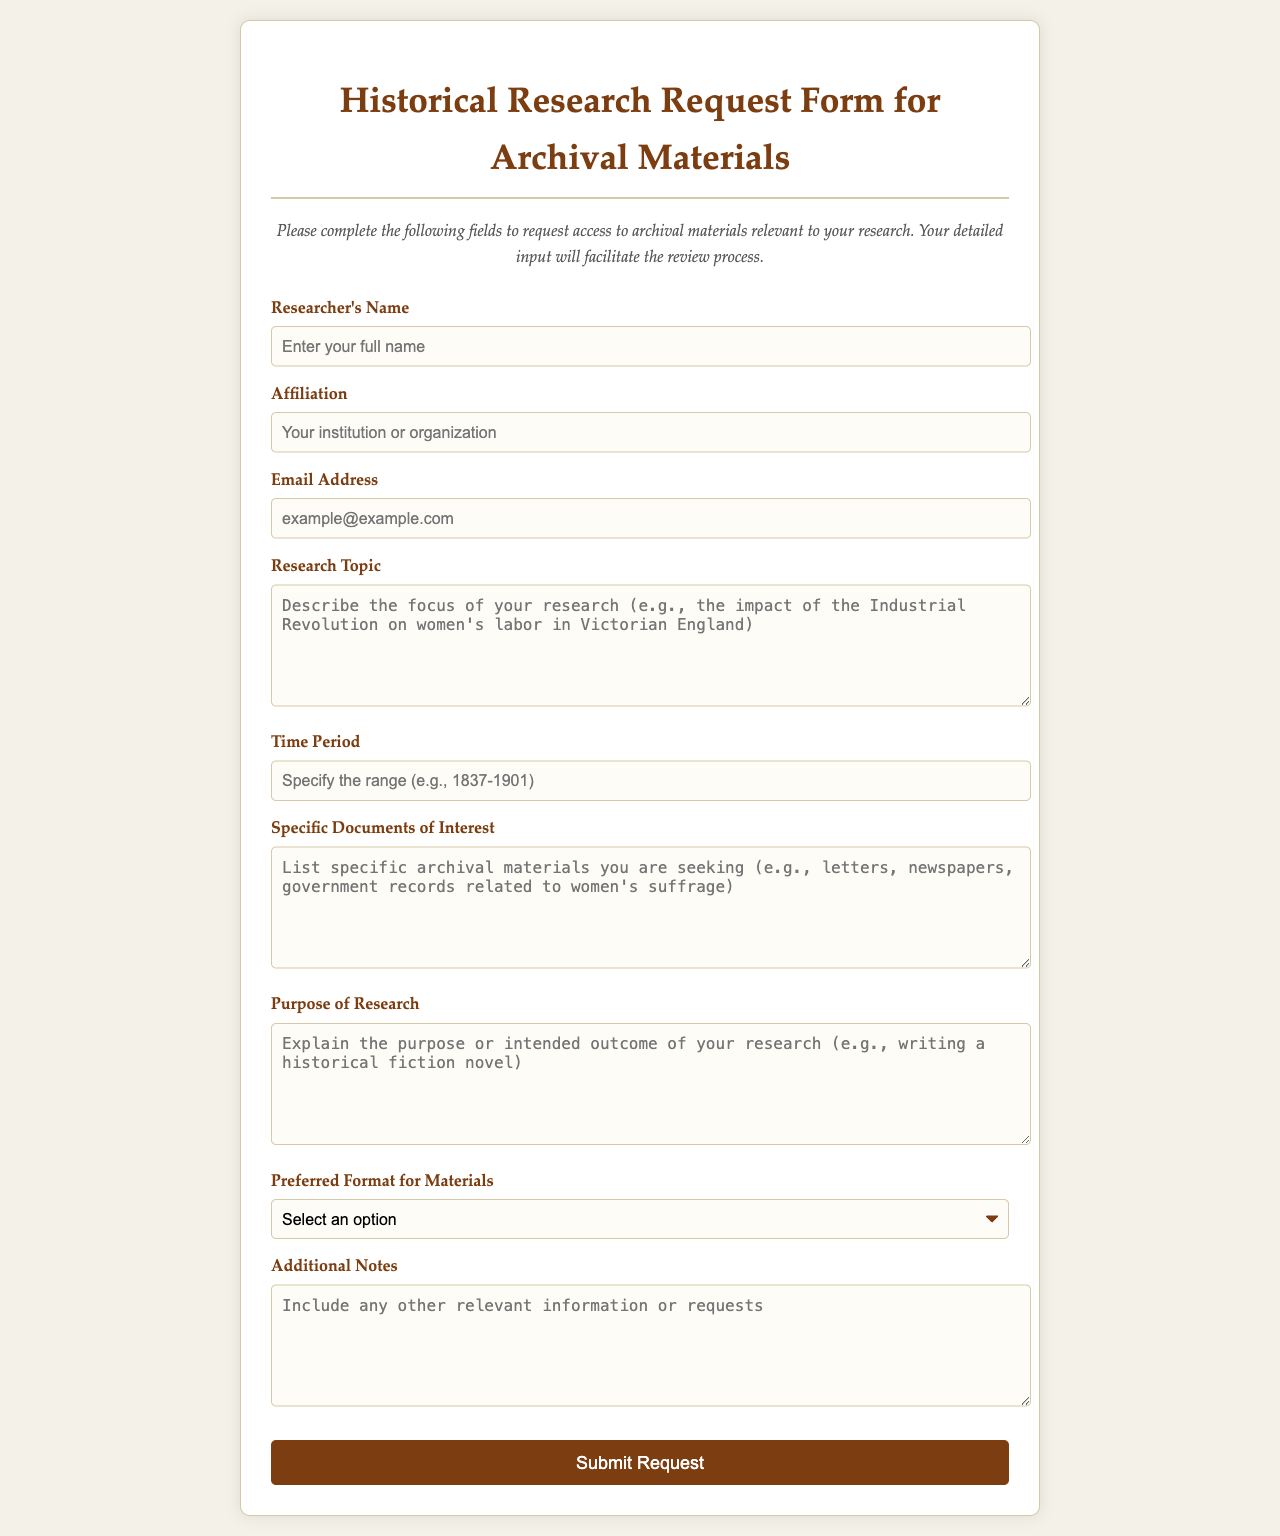What is the title of the form? The title of the form is presented prominently at the top of the document.
Answer: Historical Research Request Form for Archival Materials What type of input field is used for the research topic? The form uses a specific type of input field for describing the research topic in detail.
Answer: Textarea What is the purpose of the research? This section allows the researcher to describe the intended outcome or aim of their study.
Answer: Purpose of Research What is the time period input prompt? The prompt specifies what the researcher needs to input regarding time.
Answer: Specify the range What options are available for preferred format? The document lists different formats that materials can be accessed in.
Answer: Digital copies, Physical access, Both How many fields require a response in the form? This includes all fields that are mandatory for completing the request.
Answer: Seven What is the color of the button for submission? The button's color is specified in the document, influencing the user's interaction.
Answer: White What instruction is provided at the top of the form? The underlined instructions guide the user on how to fill out the request form.
Answer: Complete the following fields Which organization is the input for Affiliation requesting? The affiliation field asks for the researcher’s institutional or organizational information.
Answer: Your institution or organization What additional input is optional at the end of the form? This space allows for extra information beyond the required entries.
Answer: Additional Notes 